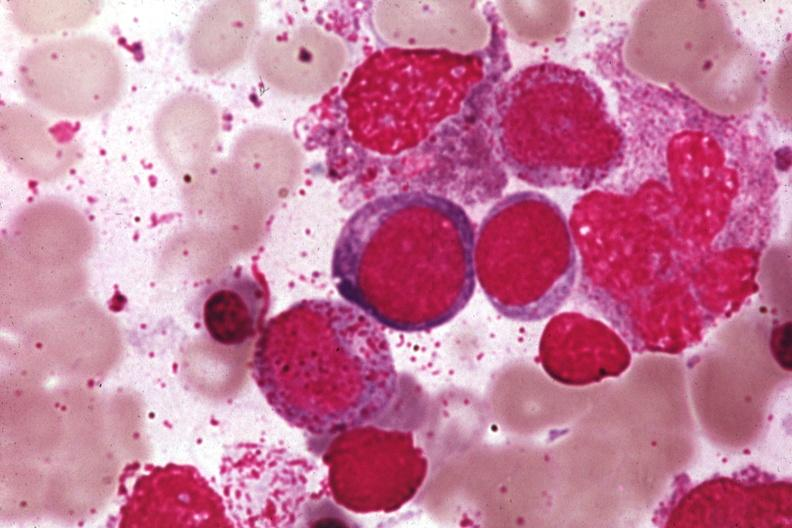does chronic myelogenous leukemia show wrights?
Answer the question using a single word or phrase. No 